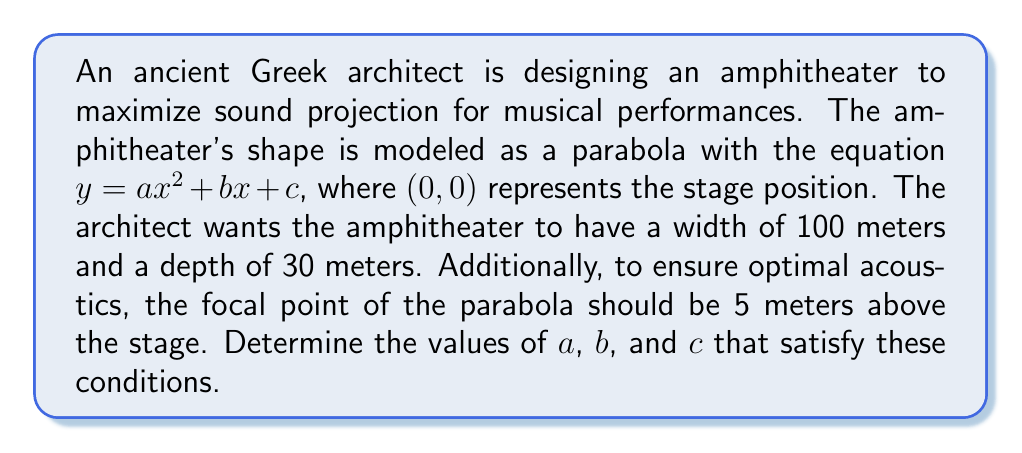What is the answer to this math problem? Let's approach this step-by-step:

1) The parabola passes through $(0, 0)$, so $c = 0$.

2) The width is 100 meters, so the x-coordinates at the edges are $-50$ and $50$. The depth is 30 meters, so the y-coordinate at these points is 30. We can write:

   $30 = a(50)^2 + b(50)$
   $30 = a(-50)^2 + b(-50)$

3) Subtracting these equations:

   $0 = 100b$
   $b = 0$

4) Substituting back:

   $30 = a(2500)$
   $a = \frac{30}{2500} = 0.012$

5) Now, we need to check if this satisfies the focal point condition. The focal point of a parabola $y = ax^2$ is at $(0, \frac{1}{4a})$. We want this to be 5:

   $5 = \frac{1}{4(0.012)}$

   This checks out.

6) Therefore, our parabola equation is:

   $y = 0.012x^2$

[asy]
import graph;
size(200,100);
real f(real x) {return 0.012*x^2;}
draw(graph(f,-50,50));
draw((-50,0)--(50,0),arrow=Arrow(TeXHead));
draw((0,0)--(0,30),arrow=Arrow(TeXHead));
label("x",(50,0),E);
label("y",(0,30),N);
dot((0,5));
label("Focal point",(0,5),E);
dot((0,0));
label("Stage",(0,0),SW);
[/asy]
Answer: $a = 0.012$, $b = 0$, $c = 0$
The equation of the amphitheater is $y = 0.012x^2$ 